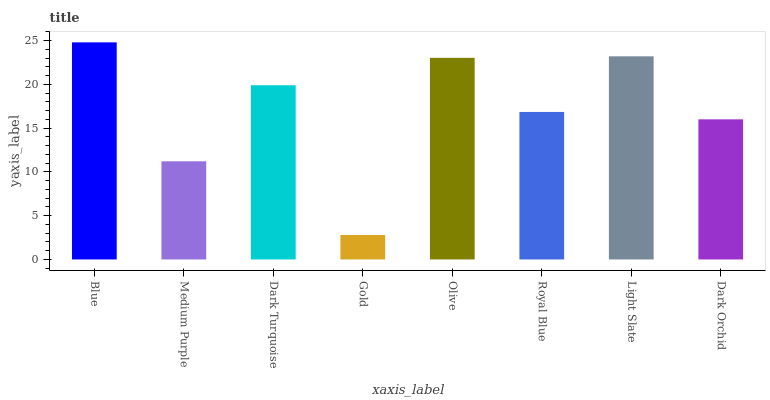Is Gold the minimum?
Answer yes or no. Yes. Is Blue the maximum?
Answer yes or no. Yes. Is Medium Purple the minimum?
Answer yes or no. No. Is Medium Purple the maximum?
Answer yes or no. No. Is Blue greater than Medium Purple?
Answer yes or no. Yes. Is Medium Purple less than Blue?
Answer yes or no. Yes. Is Medium Purple greater than Blue?
Answer yes or no. No. Is Blue less than Medium Purple?
Answer yes or no. No. Is Dark Turquoise the high median?
Answer yes or no. Yes. Is Royal Blue the low median?
Answer yes or no. Yes. Is Olive the high median?
Answer yes or no. No. Is Dark Orchid the low median?
Answer yes or no. No. 